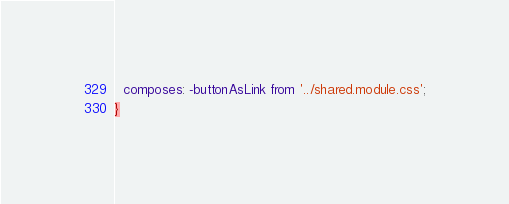<code> <loc_0><loc_0><loc_500><loc_500><_CSS_>  composes: -buttonAsLink from '../shared.module.css';
}
</code> 